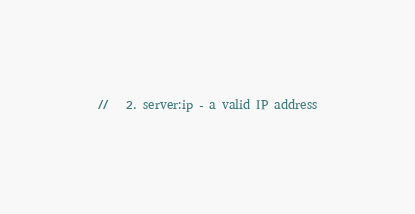<code> <loc_0><loc_0><loc_500><loc_500><_JavaScript_>//   2. server:ip - a valid IP address</code> 